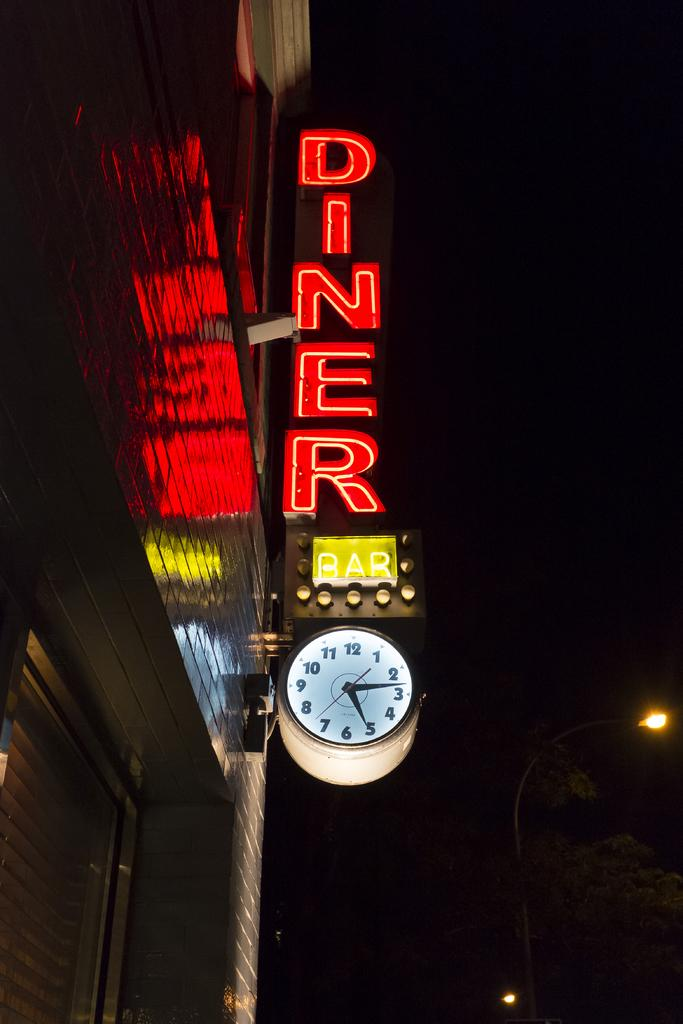<image>
Share a concise interpretation of the image provided. A diner sign lit up by neon on a post 